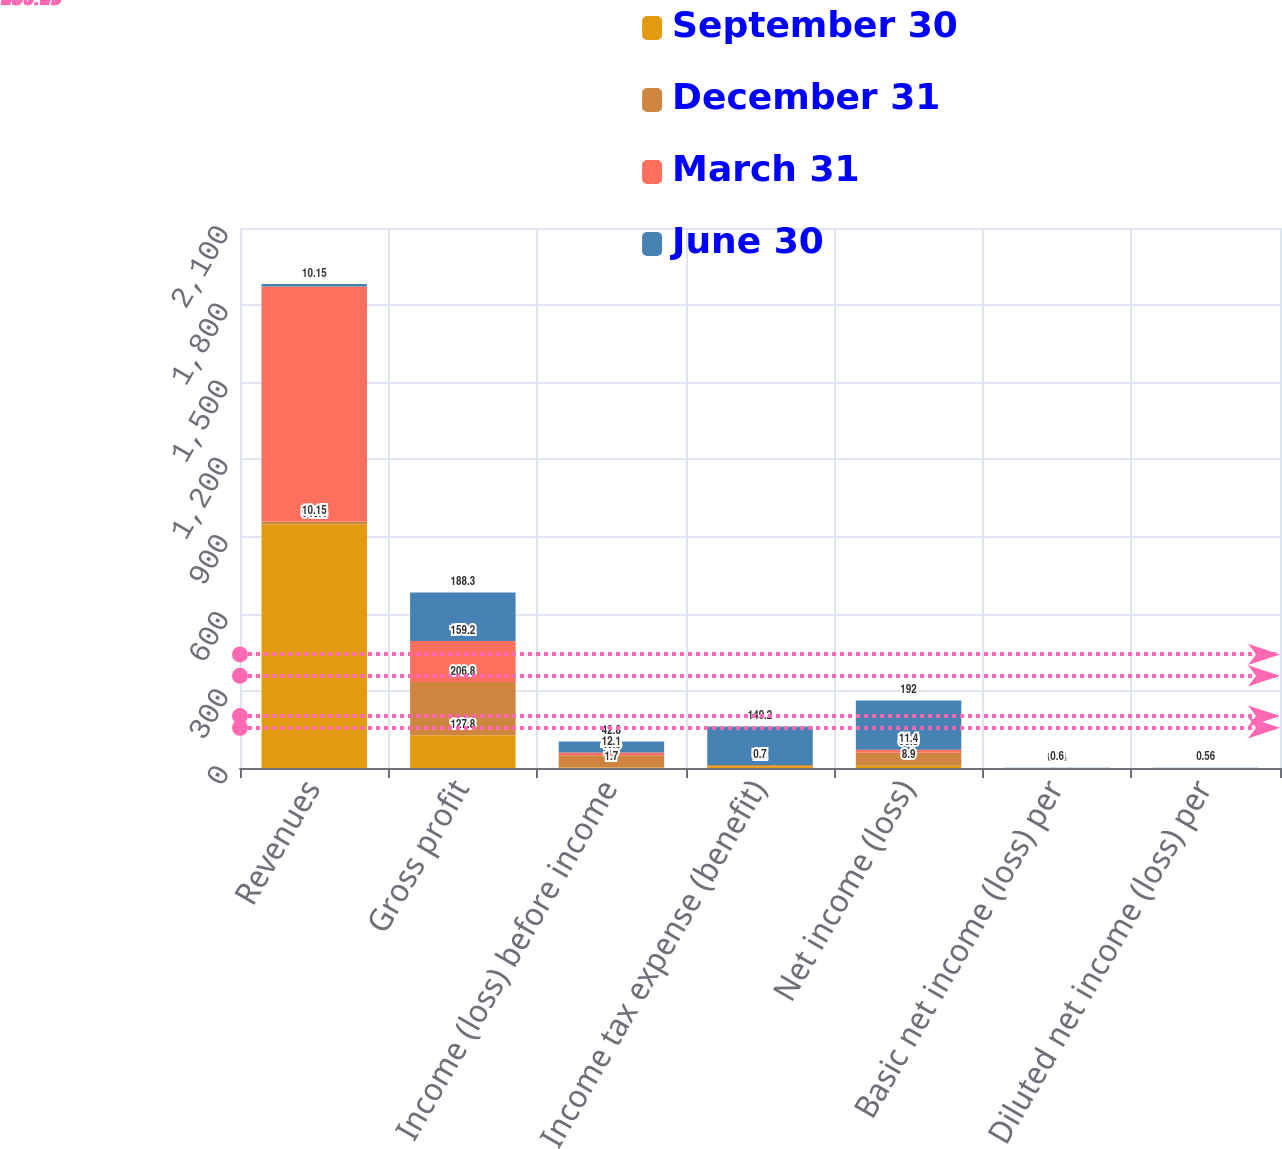<chart> <loc_0><loc_0><loc_500><loc_500><stacked_bar_chart><ecel><fcel>Revenues<fcel>Gross profit<fcel>Income (loss) before income<fcel>Income tax expense (benefit)<fcel>Net income (loss)<fcel>Basic net income (loss) per<fcel>Diluted net income (loss) per<nl><fcel>September 30<fcel>948.4<fcel>127.8<fcel>1.7<fcel>7.2<fcel>8.9<fcel>0.03<fcel>0.03<nl><fcel>December 31<fcel>10.15<fcel>206.8<fcel>46.3<fcel>4.2<fcel>50.5<fcel>0.16<fcel>0.16<nl><fcel>March 31<fcel>913.5<fcel>159.2<fcel>12.1<fcel>0.7<fcel>11.4<fcel>0.04<fcel>0.04<nl><fcel>June 30<fcel>10.15<fcel>188.3<fcel>42.8<fcel>149.2<fcel>192<fcel>0.6<fcel>0.56<nl></chart> 